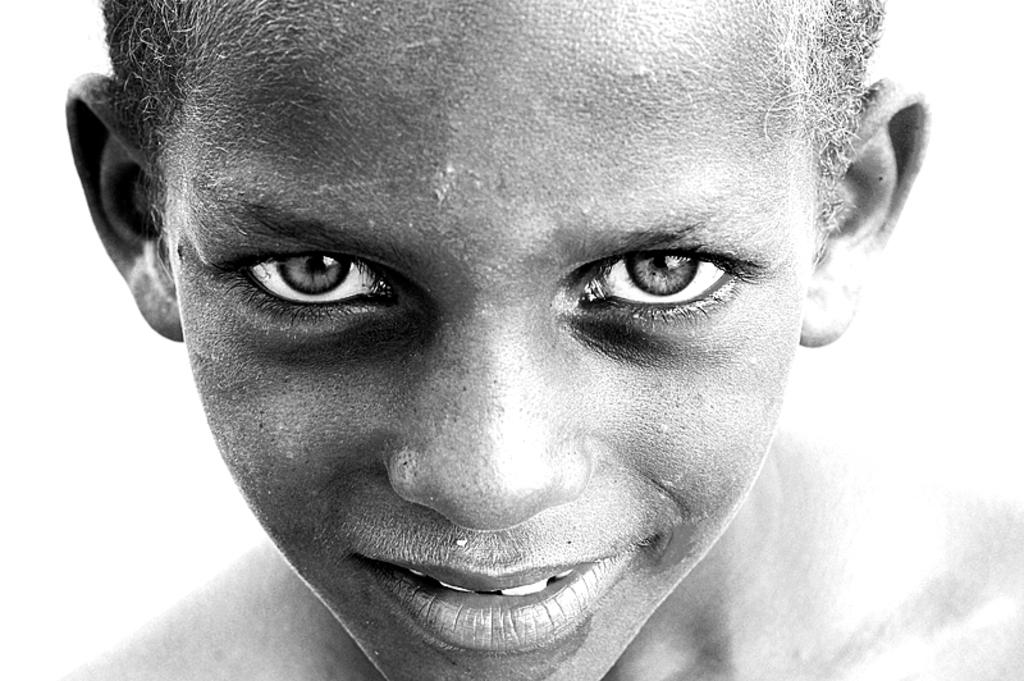What is the color scheme of the image? The image is black and white. Who or what is the main subject in the image? There is a boy in the middle of the image. What is the boy's facial expression in the image? The boy has a smiling face. What type of receipt can be seen in the boy's hand in the image? There is no receipt present in the image; the boy's hands are not visible. What is the condition of the twig that the boy is holding in the image? There is no twig present in the image; the boy is not holding anything. 